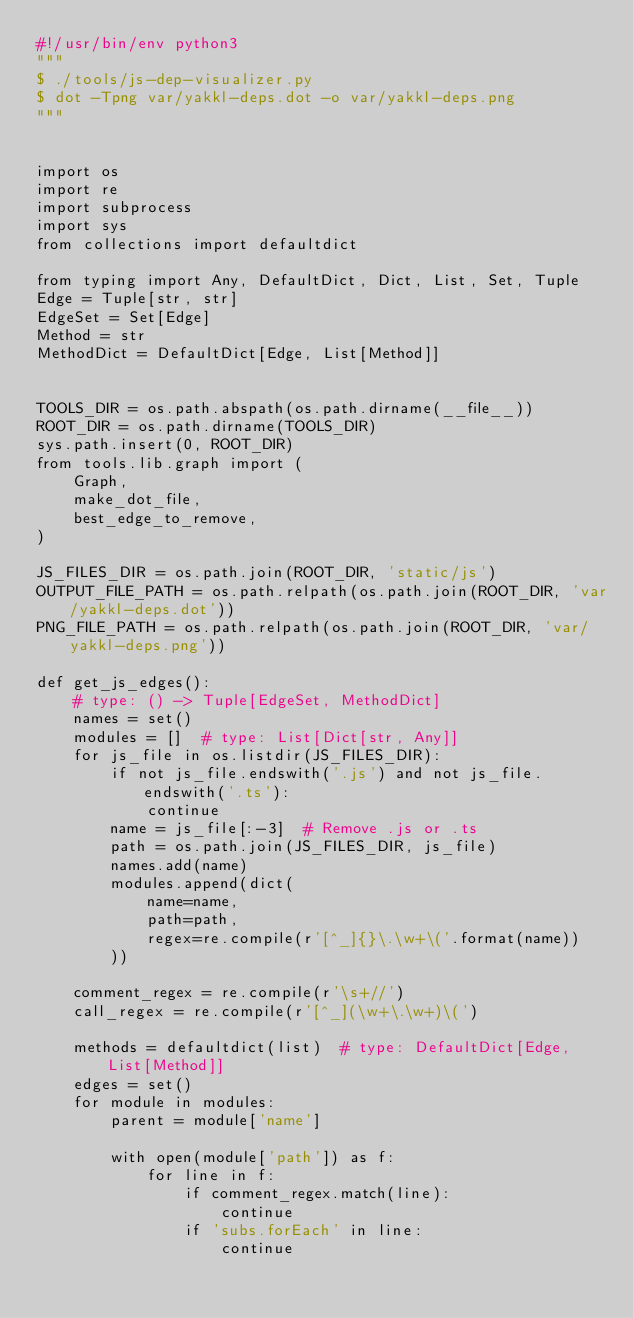<code> <loc_0><loc_0><loc_500><loc_500><_Python_>#!/usr/bin/env python3
"""
$ ./tools/js-dep-visualizer.py
$ dot -Tpng var/yakkl-deps.dot -o var/yakkl-deps.png
"""


import os
import re
import subprocess
import sys
from collections import defaultdict

from typing import Any, DefaultDict, Dict, List, Set, Tuple
Edge = Tuple[str, str]
EdgeSet = Set[Edge]
Method = str
MethodDict = DefaultDict[Edge, List[Method]]


TOOLS_DIR = os.path.abspath(os.path.dirname(__file__))
ROOT_DIR = os.path.dirname(TOOLS_DIR)
sys.path.insert(0, ROOT_DIR)
from tools.lib.graph import (
    Graph,
    make_dot_file,
    best_edge_to_remove,
)

JS_FILES_DIR = os.path.join(ROOT_DIR, 'static/js')
OUTPUT_FILE_PATH = os.path.relpath(os.path.join(ROOT_DIR, 'var/yakkl-deps.dot'))
PNG_FILE_PATH = os.path.relpath(os.path.join(ROOT_DIR, 'var/yakkl-deps.png'))

def get_js_edges():
    # type: () -> Tuple[EdgeSet, MethodDict]
    names = set()
    modules = []  # type: List[Dict[str, Any]]
    for js_file in os.listdir(JS_FILES_DIR):
        if not js_file.endswith('.js') and not js_file.endswith('.ts'):
            continue
        name = js_file[:-3]  # Remove .js or .ts
        path = os.path.join(JS_FILES_DIR, js_file)
        names.add(name)
        modules.append(dict(
            name=name,
            path=path,
            regex=re.compile(r'[^_]{}\.\w+\('.format(name))
        ))

    comment_regex = re.compile(r'\s+//')
    call_regex = re.compile(r'[^_](\w+\.\w+)\(')

    methods = defaultdict(list)  # type: DefaultDict[Edge, List[Method]]
    edges = set()
    for module in modules:
        parent = module['name']

        with open(module['path']) as f:
            for line in f:
                if comment_regex.match(line):
                    continue
                if 'subs.forEach' in line:
                    continue</code> 